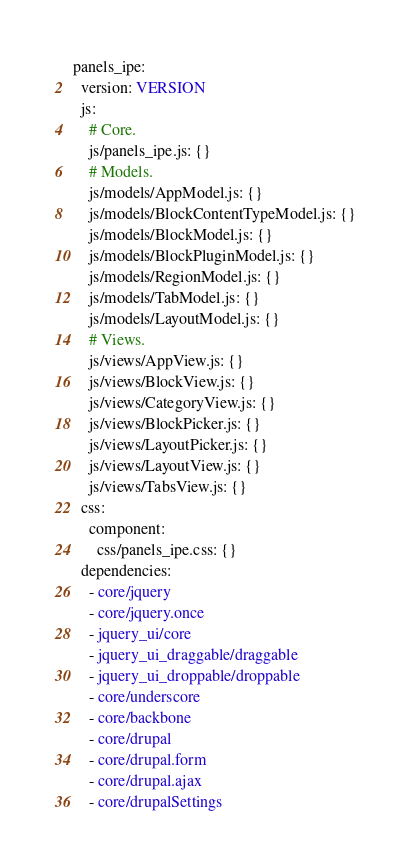Convert code to text. <code><loc_0><loc_0><loc_500><loc_500><_YAML_>panels_ipe:
  version: VERSION
  js:
    # Core.
    js/panels_ipe.js: {}
    # Models.
    js/models/AppModel.js: {}
    js/models/BlockContentTypeModel.js: {}
    js/models/BlockModel.js: {}
    js/models/BlockPluginModel.js: {}
    js/models/RegionModel.js: {}
    js/models/TabModel.js: {}
    js/models/LayoutModel.js: {}
    # Views.
    js/views/AppView.js: {}
    js/views/BlockView.js: {}
    js/views/CategoryView.js: {}
    js/views/BlockPicker.js: {}
    js/views/LayoutPicker.js: {}
    js/views/LayoutView.js: {}
    js/views/TabsView.js: {}
  css:
    component:
      css/panels_ipe.css: {}
  dependencies:
    - core/jquery
    - core/jquery.once
    - jquery_ui/core
    - jquery_ui_draggable/draggable
    - jquery_ui_droppable/droppable
    - core/underscore
    - core/backbone
    - core/drupal
    - core/drupal.form
    - core/drupal.ajax
    - core/drupalSettings
</code> 